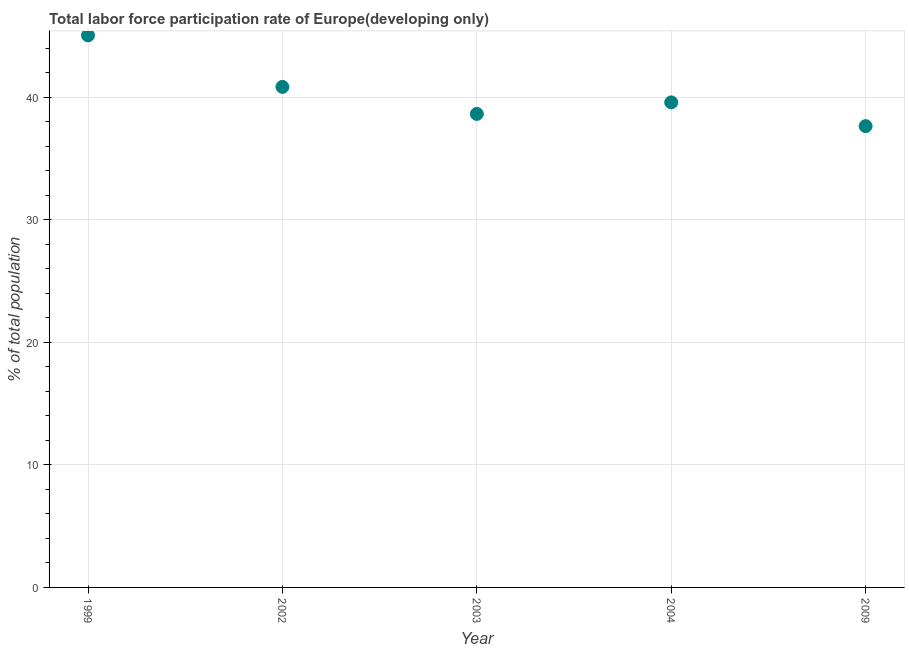What is the total labor force participation rate in 1999?
Provide a succinct answer. 45.04. Across all years, what is the maximum total labor force participation rate?
Offer a very short reply. 45.04. Across all years, what is the minimum total labor force participation rate?
Give a very brief answer. 37.64. In which year was the total labor force participation rate maximum?
Your answer should be compact. 1999. What is the sum of the total labor force participation rate?
Provide a succinct answer. 201.73. What is the difference between the total labor force participation rate in 1999 and 2009?
Offer a terse response. 7.4. What is the average total labor force participation rate per year?
Give a very brief answer. 40.35. What is the median total labor force participation rate?
Ensure brevity in your answer.  39.57. Do a majority of the years between 2002 and 2004 (inclusive) have total labor force participation rate greater than 10 %?
Provide a succinct answer. Yes. What is the ratio of the total labor force participation rate in 2002 to that in 2009?
Your response must be concise. 1.09. Is the total labor force participation rate in 1999 less than that in 2003?
Your answer should be very brief. No. Is the difference between the total labor force participation rate in 2003 and 2009 greater than the difference between any two years?
Ensure brevity in your answer.  No. What is the difference between the highest and the second highest total labor force participation rate?
Offer a terse response. 4.2. Is the sum of the total labor force participation rate in 1999 and 2002 greater than the maximum total labor force participation rate across all years?
Keep it short and to the point. Yes. What is the difference between the highest and the lowest total labor force participation rate?
Offer a terse response. 7.4. How many dotlines are there?
Make the answer very short. 1. Does the graph contain any zero values?
Give a very brief answer. No. Does the graph contain grids?
Your answer should be compact. Yes. What is the title of the graph?
Offer a terse response. Total labor force participation rate of Europe(developing only). What is the label or title of the Y-axis?
Your answer should be compact. % of total population. What is the % of total population in 1999?
Your answer should be very brief. 45.04. What is the % of total population in 2002?
Keep it short and to the point. 40.84. What is the % of total population in 2003?
Give a very brief answer. 38.64. What is the % of total population in 2004?
Ensure brevity in your answer.  39.57. What is the % of total population in 2009?
Provide a short and direct response. 37.64. What is the difference between the % of total population in 1999 and 2002?
Provide a succinct answer. 4.2. What is the difference between the % of total population in 1999 and 2003?
Your answer should be compact. 6.41. What is the difference between the % of total population in 1999 and 2004?
Offer a terse response. 5.47. What is the difference between the % of total population in 1999 and 2009?
Offer a terse response. 7.4. What is the difference between the % of total population in 2002 and 2003?
Your response must be concise. 2.2. What is the difference between the % of total population in 2002 and 2004?
Provide a succinct answer. 1.26. What is the difference between the % of total population in 2002 and 2009?
Your response must be concise. 3.2. What is the difference between the % of total population in 2003 and 2004?
Make the answer very short. -0.94. What is the difference between the % of total population in 2003 and 2009?
Ensure brevity in your answer.  1. What is the difference between the % of total population in 2004 and 2009?
Offer a very short reply. 1.94. What is the ratio of the % of total population in 1999 to that in 2002?
Your response must be concise. 1.1. What is the ratio of the % of total population in 1999 to that in 2003?
Make the answer very short. 1.17. What is the ratio of the % of total population in 1999 to that in 2004?
Offer a terse response. 1.14. What is the ratio of the % of total population in 1999 to that in 2009?
Offer a terse response. 1.2. What is the ratio of the % of total population in 2002 to that in 2003?
Ensure brevity in your answer.  1.06. What is the ratio of the % of total population in 2002 to that in 2004?
Provide a short and direct response. 1.03. What is the ratio of the % of total population in 2002 to that in 2009?
Your response must be concise. 1.08. What is the ratio of the % of total population in 2003 to that in 2009?
Provide a short and direct response. 1.03. What is the ratio of the % of total population in 2004 to that in 2009?
Your response must be concise. 1.05. 